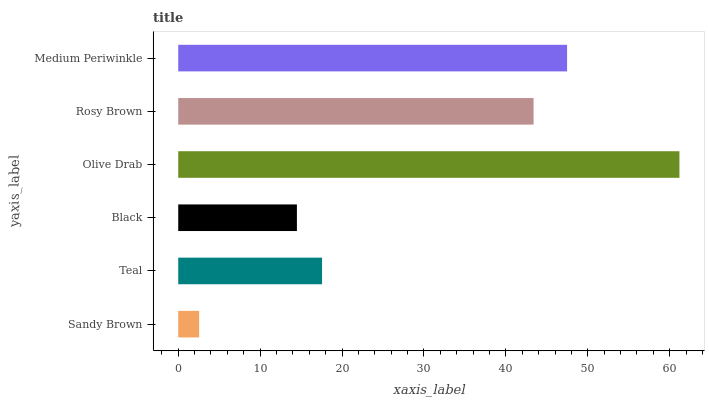Is Sandy Brown the minimum?
Answer yes or no. Yes. Is Olive Drab the maximum?
Answer yes or no. Yes. Is Teal the minimum?
Answer yes or no. No. Is Teal the maximum?
Answer yes or no. No. Is Teal greater than Sandy Brown?
Answer yes or no. Yes. Is Sandy Brown less than Teal?
Answer yes or no. Yes. Is Sandy Brown greater than Teal?
Answer yes or no. No. Is Teal less than Sandy Brown?
Answer yes or no. No. Is Rosy Brown the high median?
Answer yes or no. Yes. Is Teal the low median?
Answer yes or no. Yes. Is Medium Periwinkle the high median?
Answer yes or no. No. Is Sandy Brown the low median?
Answer yes or no. No. 